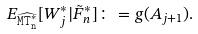<formula> <loc_0><loc_0><loc_500><loc_500>E _ { { \widehat { \tt M T ^ { * } _ { n } } } } [ W _ { j } ^ { * } | \tilde { F } _ { n } ^ { * } ] \colon = g ( A _ { j + 1 } ) .</formula> 